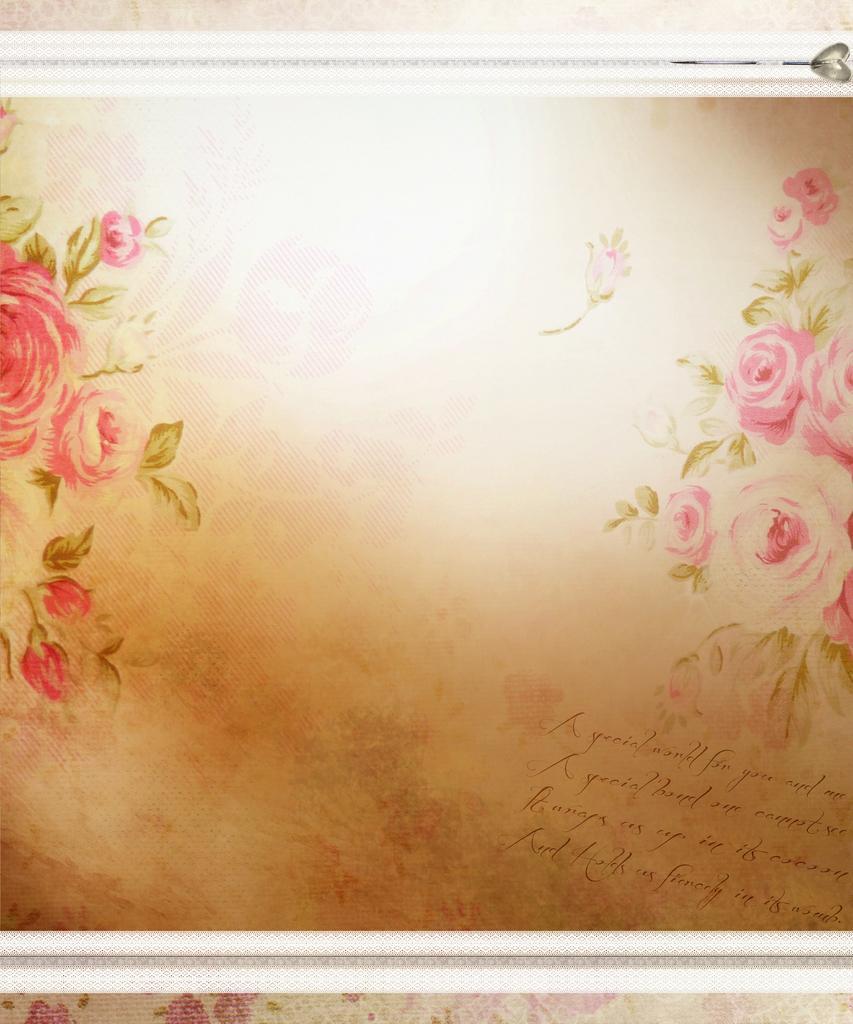In one or two sentences, can you explain what this image depicts? In this image I can see the cream and brown colored surface on which I can see few flowers which are pink in color and few leaves which are green in color. I can see the white colored boundaries to it and few words written on it. 